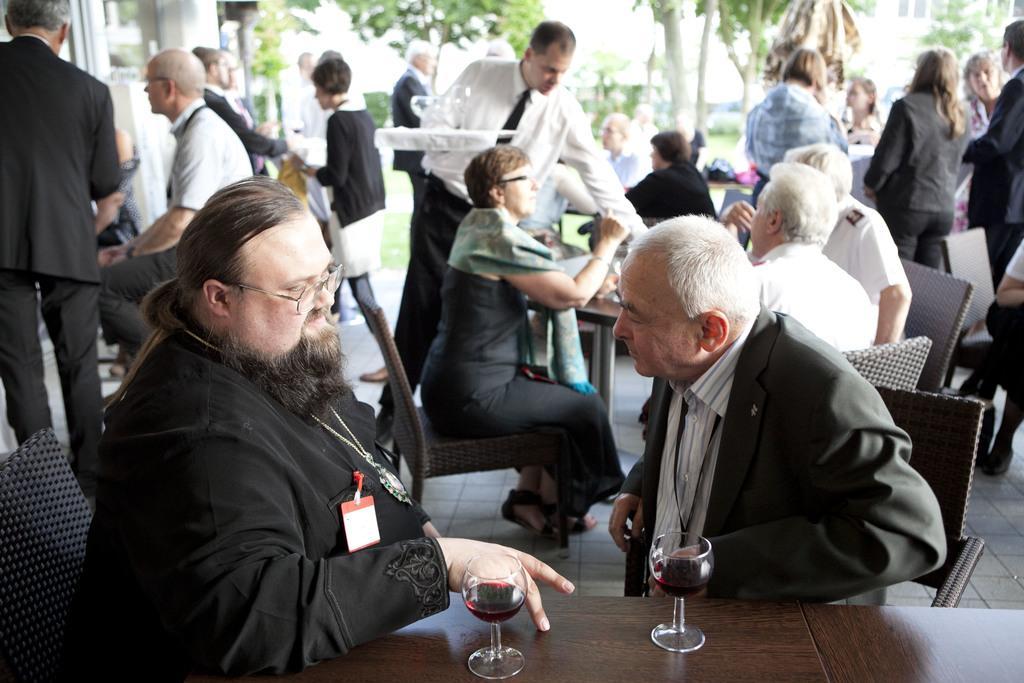How would you summarize this image in a sentence or two? In this image i can see a group of people are sitting on a chair in front of a table. I can also see there are some men who are walking on the floor. 